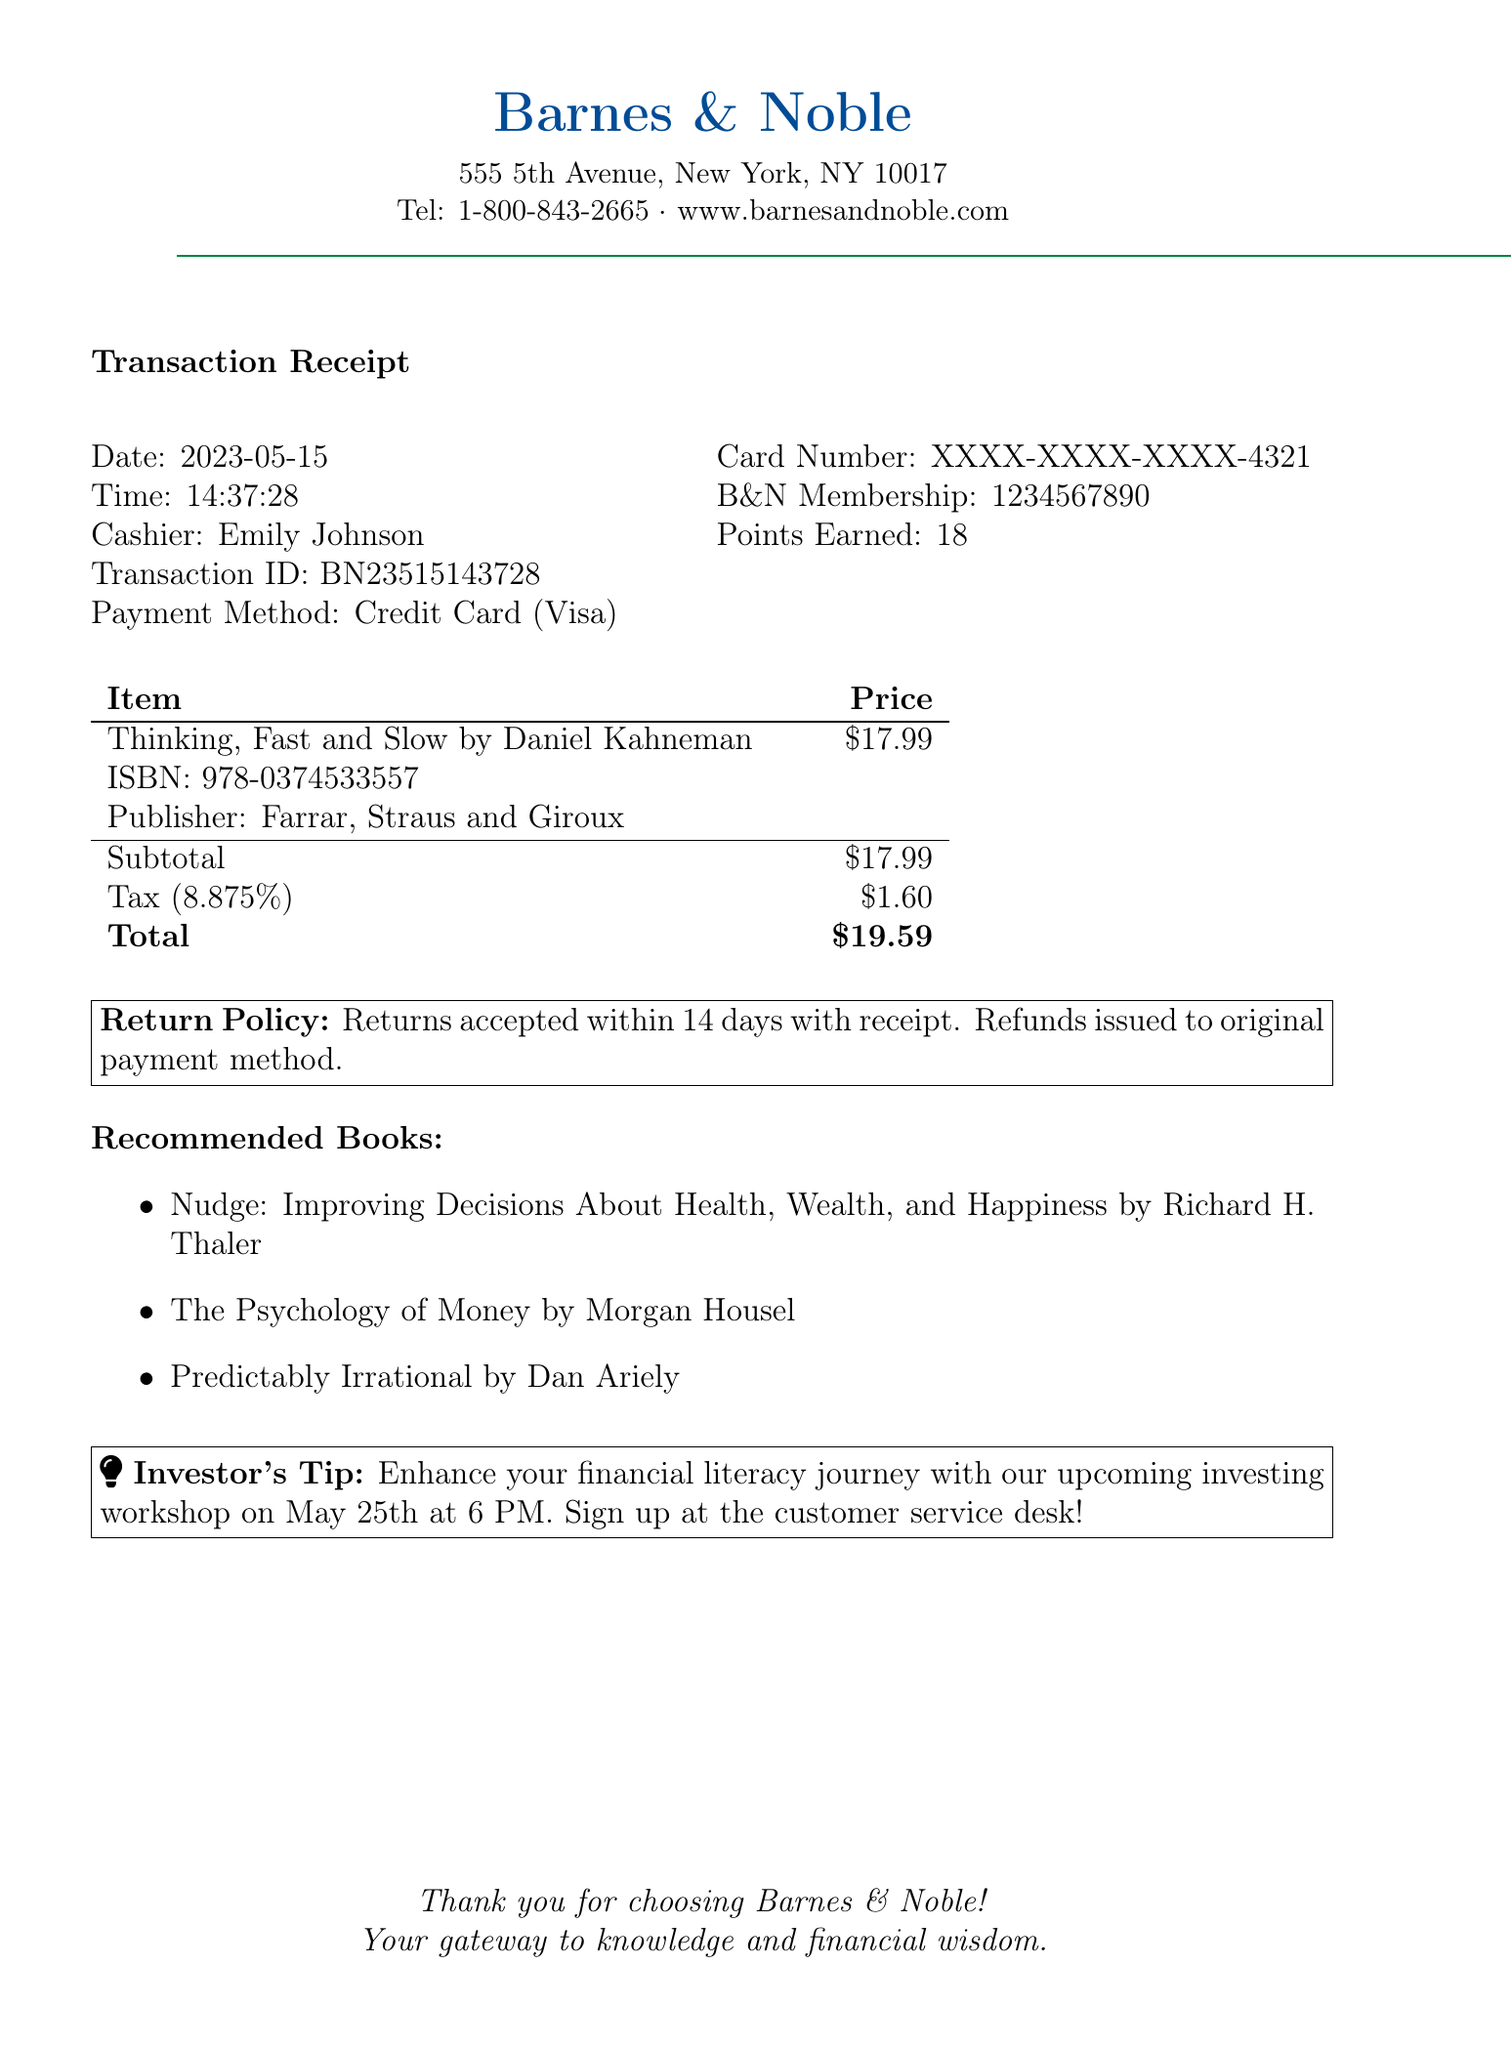What is the store name? The store name is the primary identifier of the location where the purchase was made.
Answer: Barnes & Noble What is the total amount spent? The total amount is the final charge that includes both the price and tax.
Answer: $19.59 Who is the author of the book purchased? The author is a key detail related to the item purchased, providing insight into its credibility and authority.
Answer: Daniel Kahneman What date was the book purchased? The purchase date is important for tracking spending and potential returns.
Answer: 2023-05-15 What is the ISBN of the book? The International Standard Book Number helps in uniquely identifying the book in a database.
Answer: 978-0374533557 What payment method was used? The payment method indicates how the transaction was completed and can affect the buyer's credit use.
Answer: Credit Card How many points were earned with this purchase? Points earned often relate to a loyalty program and encourage future engagements.
Answer: 18 What is the return policy duration? The return policy duration informs the buyer how long they have to return the item if needed.
Answer: 14 days What is the tax amount applied to the purchase? The tax amount gives insight into the additional costs added to the item's price.
Answer: $1.60 What workshop is mentioned in the document? The workshop provides additional opportunities for financial learning and investing skills.
Answer: Investing workshop 